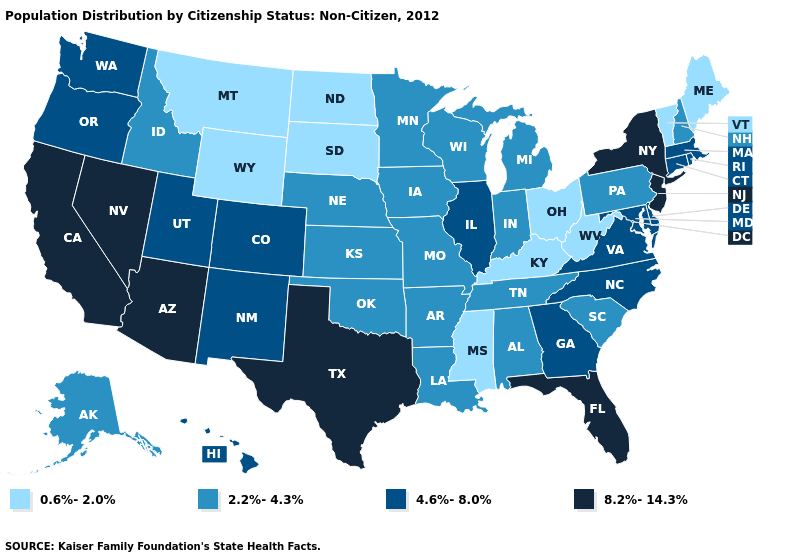What is the value of South Carolina?
Keep it brief. 2.2%-4.3%. What is the value of Colorado?
Write a very short answer. 4.6%-8.0%. Name the states that have a value in the range 2.2%-4.3%?
Answer briefly. Alabama, Alaska, Arkansas, Idaho, Indiana, Iowa, Kansas, Louisiana, Michigan, Minnesota, Missouri, Nebraska, New Hampshire, Oklahoma, Pennsylvania, South Carolina, Tennessee, Wisconsin. What is the value of Idaho?
Concise answer only. 2.2%-4.3%. Among the states that border Connecticut , does Massachusetts have the lowest value?
Quick response, please. Yes. Does California have the highest value in the USA?
Quick response, please. Yes. How many symbols are there in the legend?
Give a very brief answer. 4. Which states have the lowest value in the MidWest?
Keep it brief. North Dakota, Ohio, South Dakota. Does Maryland have a lower value than Florida?
Short answer required. Yes. Among the states that border Wisconsin , does Illinois have the lowest value?
Answer briefly. No. What is the value of North Carolina?
Write a very short answer. 4.6%-8.0%. Does Colorado have the lowest value in the West?
Answer briefly. No. What is the value of Tennessee?
Write a very short answer. 2.2%-4.3%. What is the highest value in the USA?
Concise answer only. 8.2%-14.3%. Among the states that border Utah , which have the highest value?
Quick response, please. Arizona, Nevada. 